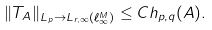Convert formula to latex. <formula><loc_0><loc_0><loc_500><loc_500>\| T _ { A } \| _ { L _ { p } \to L _ { r , \infty } ( \ell _ { \infty } ^ { M } ) } \leq C h _ { p , q } ( A ) .</formula> 